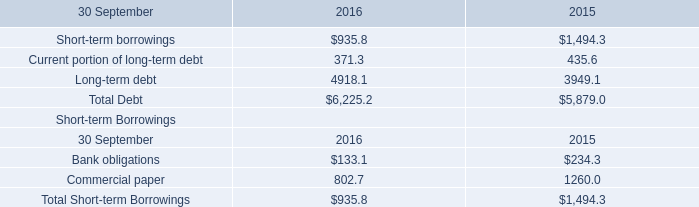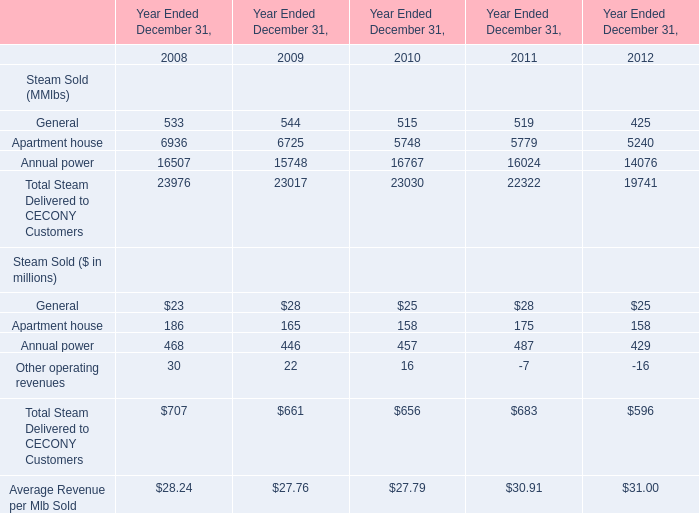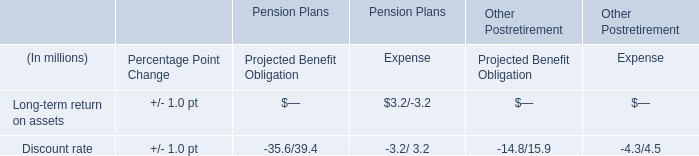What was the total amount of Steam Sold ($ in millions) in 2008? (in million) 
Computations: (((23 + 186) + 468) + 30)
Answer: 707.0. 